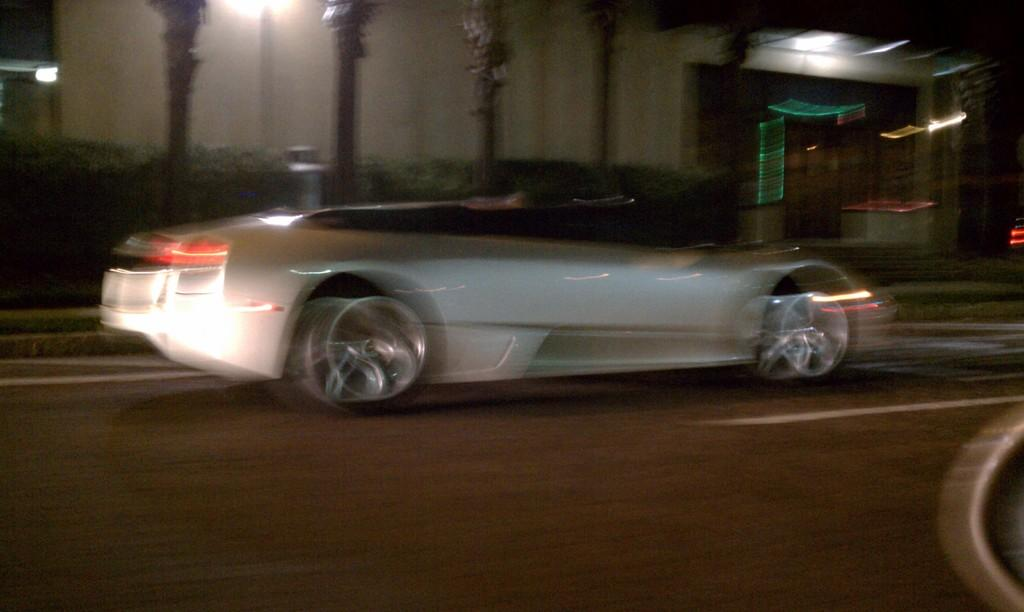What is on the road in the image? There is a vehicle on the road in the image. What type of vegetation can be seen in the image? There are plants and trees in the image. What type of structure is visible in the image? There is a building in the image. What size pan is being used in the image? There is no pan present in the image. 